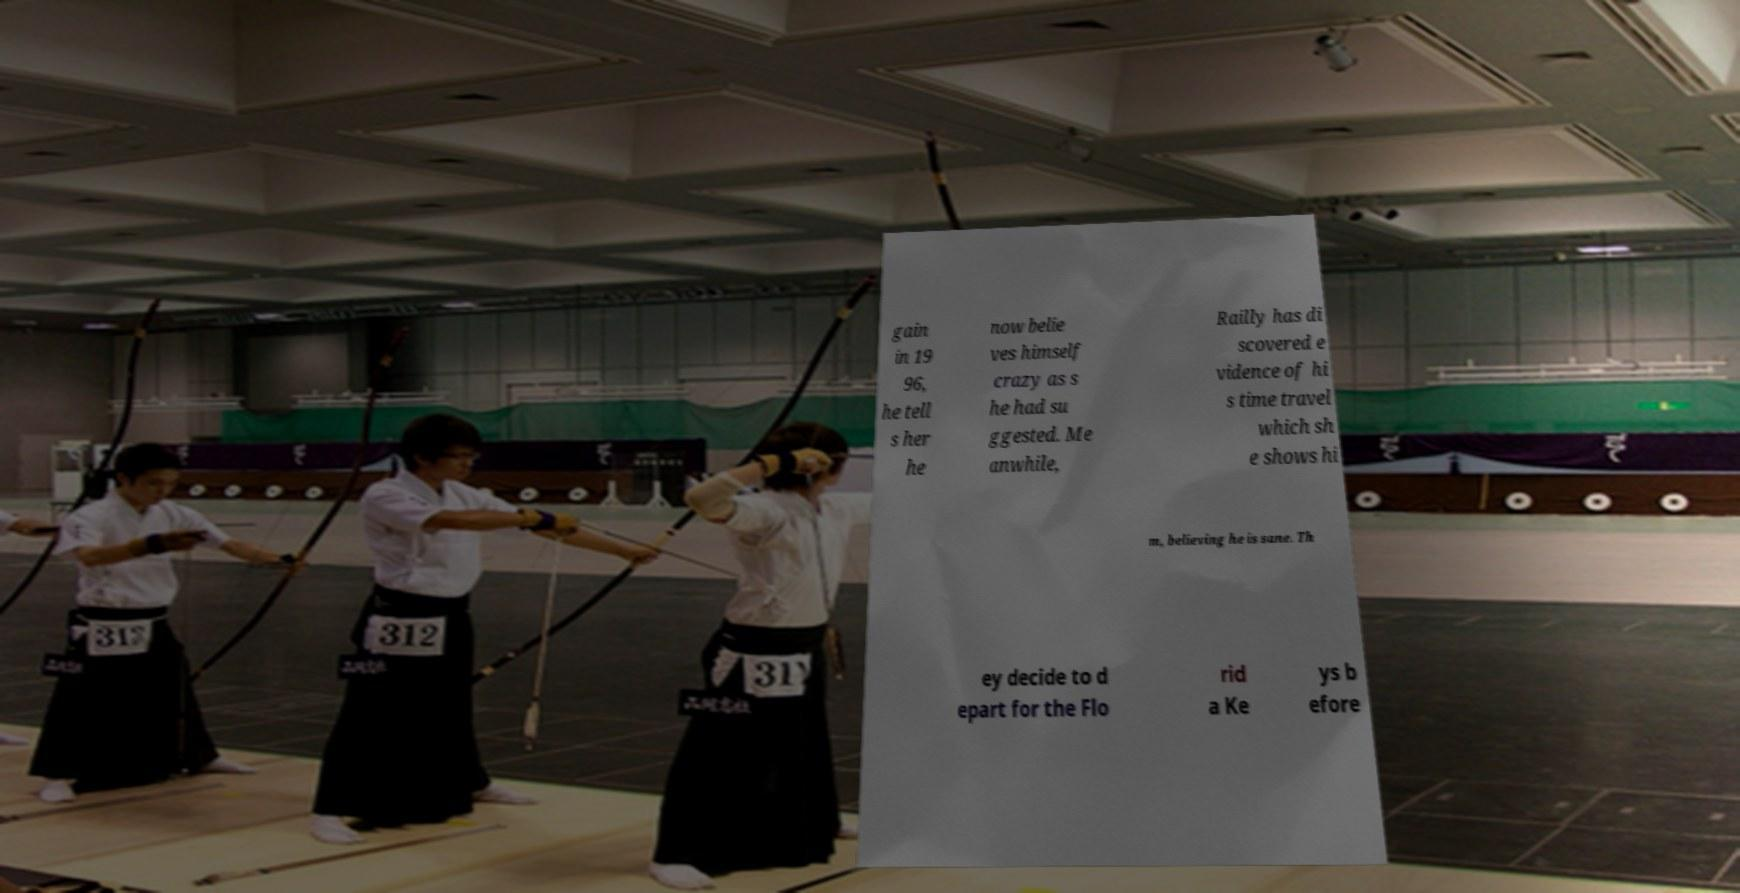I need the written content from this picture converted into text. Can you do that? gain in 19 96, he tell s her he now belie ves himself crazy as s he had su ggested. Me anwhile, Railly has di scovered e vidence of hi s time travel which sh e shows hi m, believing he is sane. Th ey decide to d epart for the Flo rid a Ke ys b efore 